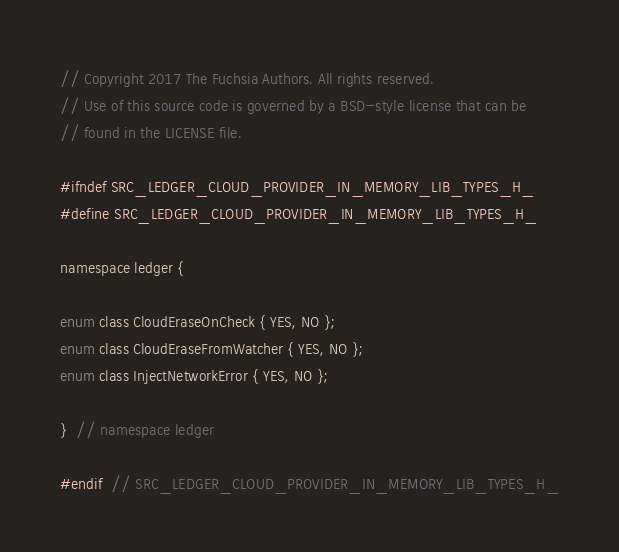Convert code to text. <code><loc_0><loc_0><loc_500><loc_500><_C_>// Copyright 2017 The Fuchsia Authors. All rights reserved.
// Use of this source code is governed by a BSD-style license that can be
// found in the LICENSE file.

#ifndef SRC_LEDGER_CLOUD_PROVIDER_IN_MEMORY_LIB_TYPES_H_
#define SRC_LEDGER_CLOUD_PROVIDER_IN_MEMORY_LIB_TYPES_H_

namespace ledger {

enum class CloudEraseOnCheck { YES, NO };
enum class CloudEraseFromWatcher { YES, NO };
enum class InjectNetworkError { YES, NO };

}  // namespace ledger

#endif  // SRC_LEDGER_CLOUD_PROVIDER_IN_MEMORY_LIB_TYPES_H_
</code> 